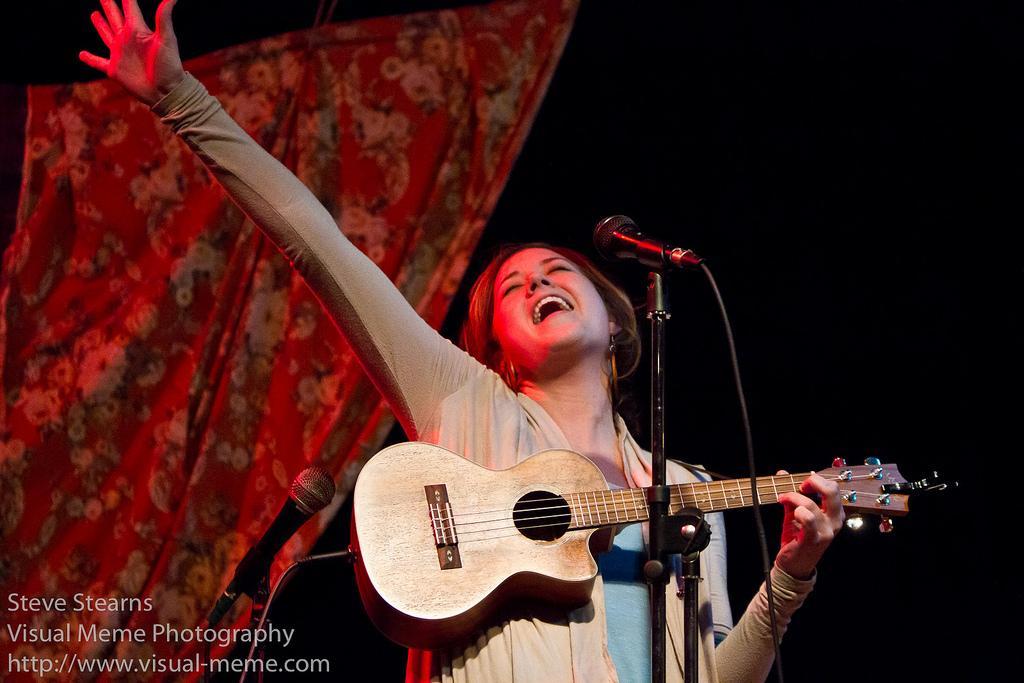How would you summarize this image in a sentence or two? Here we can see a woman playing a guitar and singing with microphone in front of her 